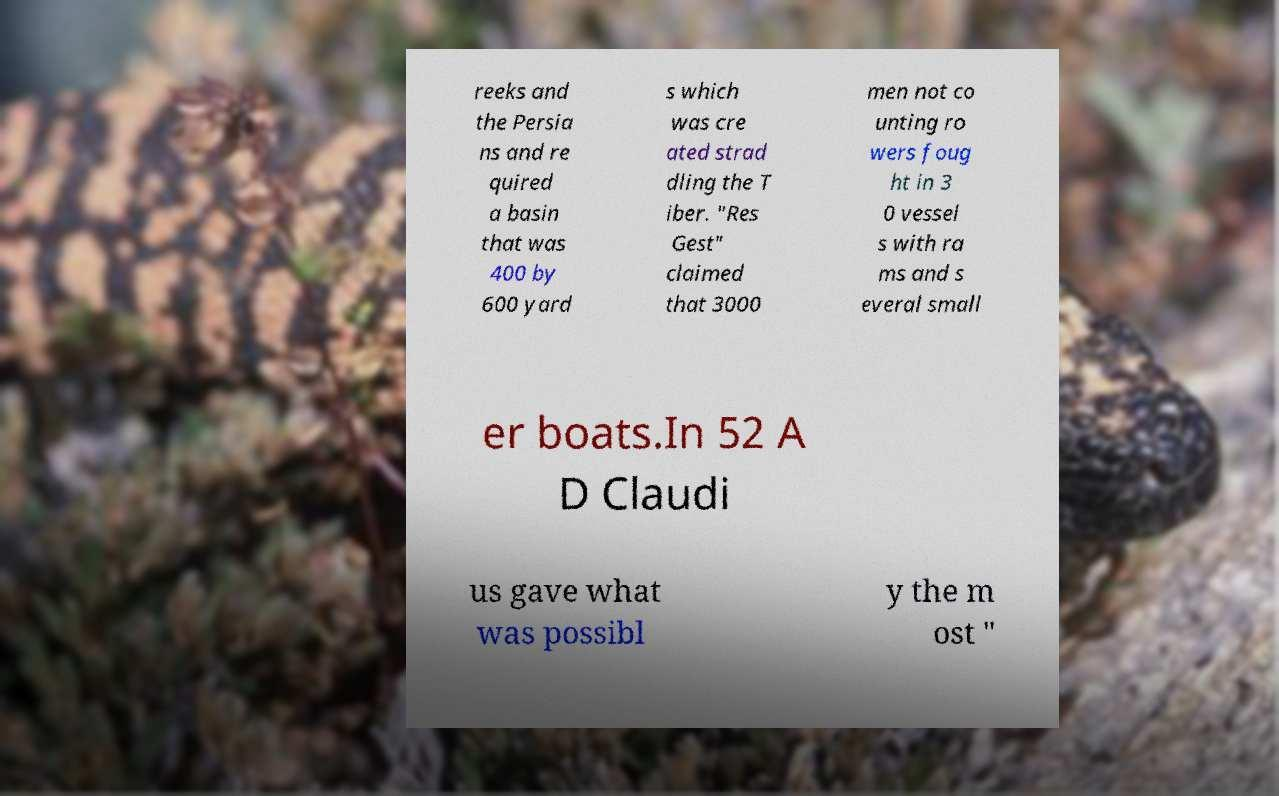There's text embedded in this image that I need extracted. Can you transcribe it verbatim? reeks and the Persia ns and re quired a basin that was 400 by 600 yard s which was cre ated strad dling the T iber. "Res Gest" claimed that 3000 men not co unting ro wers foug ht in 3 0 vessel s with ra ms and s everal small er boats.In 52 A D Claudi us gave what was possibl y the m ost " 